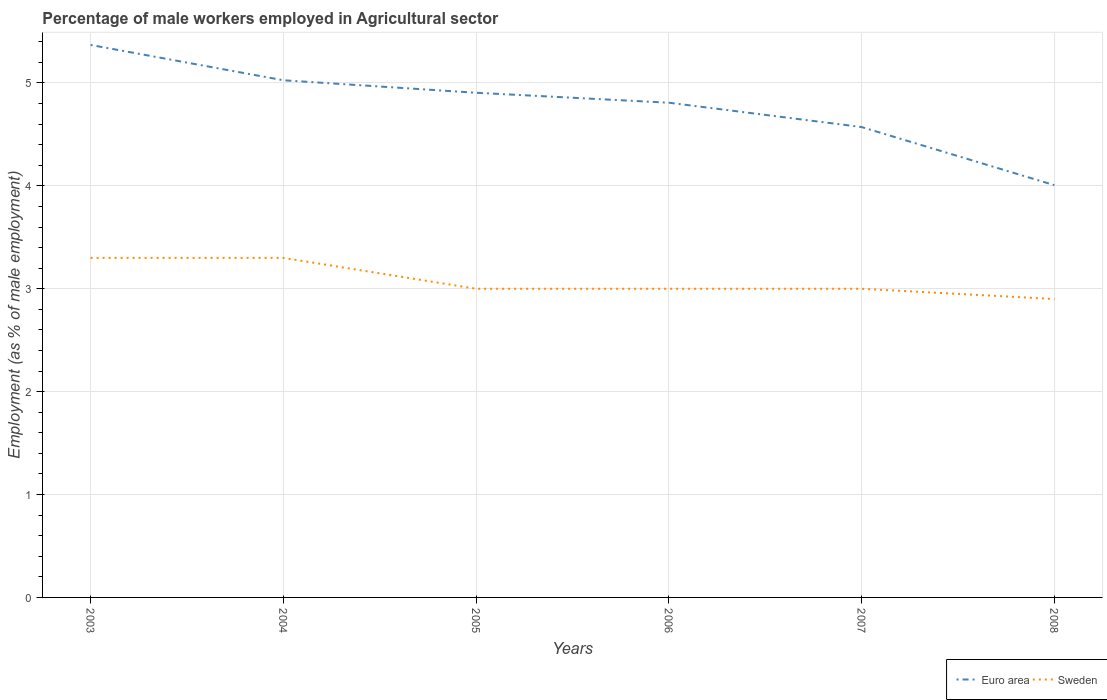Does the line corresponding to Euro area intersect with the line corresponding to Sweden?
Offer a very short reply. No. Across all years, what is the maximum percentage of male workers employed in Agricultural sector in Sweden?
Ensure brevity in your answer.  2.9. What is the total percentage of male workers employed in Agricultural sector in Euro area in the graph?
Provide a short and direct response. 0.45. What is the difference between the highest and the second highest percentage of male workers employed in Agricultural sector in Sweden?
Your answer should be compact. 0.4. How many lines are there?
Your response must be concise. 2. What is the difference between two consecutive major ticks on the Y-axis?
Make the answer very short. 1. Are the values on the major ticks of Y-axis written in scientific E-notation?
Make the answer very short. No. Does the graph contain any zero values?
Give a very brief answer. No. Does the graph contain grids?
Your response must be concise. Yes. How many legend labels are there?
Ensure brevity in your answer.  2. How are the legend labels stacked?
Make the answer very short. Horizontal. What is the title of the graph?
Keep it short and to the point. Percentage of male workers employed in Agricultural sector. Does "Andorra" appear as one of the legend labels in the graph?
Your answer should be compact. No. What is the label or title of the Y-axis?
Offer a very short reply. Employment (as % of male employment). What is the Employment (as % of male employment) in Euro area in 2003?
Make the answer very short. 5.37. What is the Employment (as % of male employment) in Sweden in 2003?
Keep it short and to the point. 3.3. What is the Employment (as % of male employment) in Euro area in 2004?
Make the answer very short. 5.03. What is the Employment (as % of male employment) of Sweden in 2004?
Ensure brevity in your answer.  3.3. What is the Employment (as % of male employment) in Euro area in 2005?
Provide a short and direct response. 4.9. What is the Employment (as % of male employment) of Euro area in 2006?
Your response must be concise. 4.81. What is the Employment (as % of male employment) in Sweden in 2006?
Make the answer very short. 3. What is the Employment (as % of male employment) in Euro area in 2007?
Provide a short and direct response. 4.57. What is the Employment (as % of male employment) in Euro area in 2008?
Offer a very short reply. 4.01. What is the Employment (as % of male employment) in Sweden in 2008?
Provide a succinct answer. 2.9. Across all years, what is the maximum Employment (as % of male employment) of Euro area?
Make the answer very short. 5.37. Across all years, what is the maximum Employment (as % of male employment) in Sweden?
Your response must be concise. 3.3. Across all years, what is the minimum Employment (as % of male employment) of Euro area?
Offer a terse response. 4.01. Across all years, what is the minimum Employment (as % of male employment) in Sweden?
Your answer should be very brief. 2.9. What is the total Employment (as % of male employment) in Euro area in the graph?
Keep it short and to the point. 28.69. What is the difference between the Employment (as % of male employment) of Euro area in 2003 and that in 2004?
Provide a short and direct response. 0.34. What is the difference between the Employment (as % of male employment) in Sweden in 2003 and that in 2004?
Your answer should be very brief. 0. What is the difference between the Employment (as % of male employment) in Euro area in 2003 and that in 2005?
Your response must be concise. 0.46. What is the difference between the Employment (as % of male employment) in Sweden in 2003 and that in 2005?
Make the answer very short. 0.3. What is the difference between the Employment (as % of male employment) of Euro area in 2003 and that in 2006?
Your answer should be compact. 0.56. What is the difference between the Employment (as % of male employment) of Sweden in 2003 and that in 2006?
Your answer should be compact. 0.3. What is the difference between the Employment (as % of male employment) of Euro area in 2003 and that in 2007?
Offer a very short reply. 0.8. What is the difference between the Employment (as % of male employment) in Euro area in 2003 and that in 2008?
Give a very brief answer. 1.36. What is the difference between the Employment (as % of male employment) in Sweden in 2003 and that in 2008?
Your answer should be very brief. 0.4. What is the difference between the Employment (as % of male employment) in Euro area in 2004 and that in 2005?
Your response must be concise. 0.12. What is the difference between the Employment (as % of male employment) in Sweden in 2004 and that in 2005?
Make the answer very short. 0.3. What is the difference between the Employment (as % of male employment) of Euro area in 2004 and that in 2006?
Give a very brief answer. 0.22. What is the difference between the Employment (as % of male employment) of Sweden in 2004 and that in 2006?
Keep it short and to the point. 0.3. What is the difference between the Employment (as % of male employment) in Euro area in 2004 and that in 2007?
Your answer should be compact. 0.45. What is the difference between the Employment (as % of male employment) in Euro area in 2004 and that in 2008?
Offer a very short reply. 1.02. What is the difference between the Employment (as % of male employment) of Euro area in 2005 and that in 2006?
Your response must be concise. 0.1. What is the difference between the Employment (as % of male employment) in Sweden in 2005 and that in 2006?
Your answer should be very brief. 0. What is the difference between the Employment (as % of male employment) of Euro area in 2005 and that in 2007?
Ensure brevity in your answer.  0.33. What is the difference between the Employment (as % of male employment) in Euro area in 2005 and that in 2008?
Offer a very short reply. 0.9. What is the difference between the Employment (as % of male employment) of Euro area in 2006 and that in 2007?
Your answer should be very brief. 0.24. What is the difference between the Employment (as % of male employment) of Sweden in 2006 and that in 2007?
Offer a terse response. 0. What is the difference between the Employment (as % of male employment) in Euro area in 2006 and that in 2008?
Ensure brevity in your answer.  0.8. What is the difference between the Employment (as % of male employment) in Sweden in 2006 and that in 2008?
Ensure brevity in your answer.  0.1. What is the difference between the Employment (as % of male employment) of Euro area in 2007 and that in 2008?
Offer a terse response. 0.56. What is the difference between the Employment (as % of male employment) of Euro area in 2003 and the Employment (as % of male employment) of Sweden in 2004?
Your answer should be very brief. 2.07. What is the difference between the Employment (as % of male employment) of Euro area in 2003 and the Employment (as % of male employment) of Sweden in 2005?
Ensure brevity in your answer.  2.37. What is the difference between the Employment (as % of male employment) in Euro area in 2003 and the Employment (as % of male employment) in Sweden in 2006?
Provide a short and direct response. 2.37. What is the difference between the Employment (as % of male employment) in Euro area in 2003 and the Employment (as % of male employment) in Sweden in 2007?
Your answer should be very brief. 2.37. What is the difference between the Employment (as % of male employment) in Euro area in 2003 and the Employment (as % of male employment) in Sweden in 2008?
Provide a short and direct response. 2.47. What is the difference between the Employment (as % of male employment) in Euro area in 2004 and the Employment (as % of male employment) in Sweden in 2005?
Your response must be concise. 2.03. What is the difference between the Employment (as % of male employment) in Euro area in 2004 and the Employment (as % of male employment) in Sweden in 2006?
Your response must be concise. 2.03. What is the difference between the Employment (as % of male employment) of Euro area in 2004 and the Employment (as % of male employment) of Sweden in 2007?
Make the answer very short. 2.03. What is the difference between the Employment (as % of male employment) in Euro area in 2004 and the Employment (as % of male employment) in Sweden in 2008?
Offer a very short reply. 2.13. What is the difference between the Employment (as % of male employment) in Euro area in 2005 and the Employment (as % of male employment) in Sweden in 2006?
Offer a terse response. 1.9. What is the difference between the Employment (as % of male employment) of Euro area in 2005 and the Employment (as % of male employment) of Sweden in 2007?
Offer a very short reply. 1.9. What is the difference between the Employment (as % of male employment) of Euro area in 2005 and the Employment (as % of male employment) of Sweden in 2008?
Offer a terse response. 2. What is the difference between the Employment (as % of male employment) of Euro area in 2006 and the Employment (as % of male employment) of Sweden in 2007?
Your answer should be very brief. 1.81. What is the difference between the Employment (as % of male employment) of Euro area in 2006 and the Employment (as % of male employment) of Sweden in 2008?
Provide a short and direct response. 1.91. What is the difference between the Employment (as % of male employment) of Euro area in 2007 and the Employment (as % of male employment) of Sweden in 2008?
Offer a terse response. 1.67. What is the average Employment (as % of male employment) in Euro area per year?
Offer a terse response. 4.78. What is the average Employment (as % of male employment) in Sweden per year?
Provide a succinct answer. 3.08. In the year 2003, what is the difference between the Employment (as % of male employment) of Euro area and Employment (as % of male employment) of Sweden?
Your answer should be compact. 2.07. In the year 2004, what is the difference between the Employment (as % of male employment) of Euro area and Employment (as % of male employment) of Sweden?
Your answer should be compact. 1.73. In the year 2005, what is the difference between the Employment (as % of male employment) of Euro area and Employment (as % of male employment) of Sweden?
Ensure brevity in your answer.  1.9. In the year 2006, what is the difference between the Employment (as % of male employment) of Euro area and Employment (as % of male employment) of Sweden?
Ensure brevity in your answer.  1.81. In the year 2007, what is the difference between the Employment (as % of male employment) in Euro area and Employment (as % of male employment) in Sweden?
Make the answer very short. 1.57. In the year 2008, what is the difference between the Employment (as % of male employment) of Euro area and Employment (as % of male employment) of Sweden?
Your answer should be very brief. 1.11. What is the ratio of the Employment (as % of male employment) of Euro area in 2003 to that in 2004?
Ensure brevity in your answer.  1.07. What is the ratio of the Employment (as % of male employment) in Euro area in 2003 to that in 2005?
Provide a succinct answer. 1.09. What is the ratio of the Employment (as % of male employment) in Sweden in 2003 to that in 2005?
Give a very brief answer. 1.1. What is the ratio of the Employment (as % of male employment) in Euro area in 2003 to that in 2006?
Offer a terse response. 1.12. What is the ratio of the Employment (as % of male employment) of Euro area in 2003 to that in 2007?
Your answer should be very brief. 1.17. What is the ratio of the Employment (as % of male employment) of Sweden in 2003 to that in 2007?
Give a very brief answer. 1.1. What is the ratio of the Employment (as % of male employment) in Euro area in 2003 to that in 2008?
Provide a succinct answer. 1.34. What is the ratio of the Employment (as % of male employment) of Sweden in 2003 to that in 2008?
Your response must be concise. 1.14. What is the ratio of the Employment (as % of male employment) of Euro area in 2004 to that in 2005?
Provide a succinct answer. 1.02. What is the ratio of the Employment (as % of male employment) of Sweden in 2004 to that in 2005?
Your answer should be compact. 1.1. What is the ratio of the Employment (as % of male employment) of Euro area in 2004 to that in 2006?
Provide a succinct answer. 1.05. What is the ratio of the Employment (as % of male employment) in Sweden in 2004 to that in 2006?
Keep it short and to the point. 1.1. What is the ratio of the Employment (as % of male employment) in Euro area in 2004 to that in 2007?
Make the answer very short. 1.1. What is the ratio of the Employment (as % of male employment) in Euro area in 2004 to that in 2008?
Provide a succinct answer. 1.25. What is the ratio of the Employment (as % of male employment) in Sweden in 2004 to that in 2008?
Give a very brief answer. 1.14. What is the ratio of the Employment (as % of male employment) in Euro area in 2005 to that in 2006?
Provide a succinct answer. 1.02. What is the ratio of the Employment (as % of male employment) of Sweden in 2005 to that in 2006?
Keep it short and to the point. 1. What is the ratio of the Employment (as % of male employment) of Euro area in 2005 to that in 2007?
Give a very brief answer. 1.07. What is the ratio of the Employment (as % of male employment) in Euro area in 2005 to that in 2008?
Ensure brevity in your answer.  1.22. What is the ratio of the Employment (as % of male employment) of Sweden in 2005 to that in 2008?
Your response must be concise. 1.03. What is the ratio of the Employment (as % of male employment) in Euro area in 2006 to that in 2007?
Keep it short and to the point. 1.05. What is the ratio of the Employment (as % of male employment) of Sweden in 2006 to that in 2007?
Ensure brevity in your answer.  1. What is the ratio of the Employment (as % of male employment) of Euro area in 2006 to that in 2008?
Your answer should be very brief. 1.2. What is the ratio of the Employment (as % of male employment) in Sweden in 2006 to that in 2008?
Your answer should be compact. 1.03. What is the ratio of the Employment (as % of male employment) in Euro area in 2007 to that in 2008?
Your answer should be very brief. 1.14. What is the ratio of the Employment (as % of male employment) in Sweden in 2007 to that in 2008?
Ensure brevity in your answer.  1.03. What is the difference between the highest and the second highest Employment (as % of male employment) in Euro area?
Give a very brief answer. 0.34. What is the difference between the highest and the second highest Employment (as % of male employment) of Sweden?
Provide a succinct answer. 0. What is the difference between the highest and the lowest Employment (as % of male employment) in Euro area?
Provide a succinct answer. 1.36. What is the difference between the highest and the lowest Employment (as % of male employment) in Sweden?
Your answer should be very brief. 0.4. 